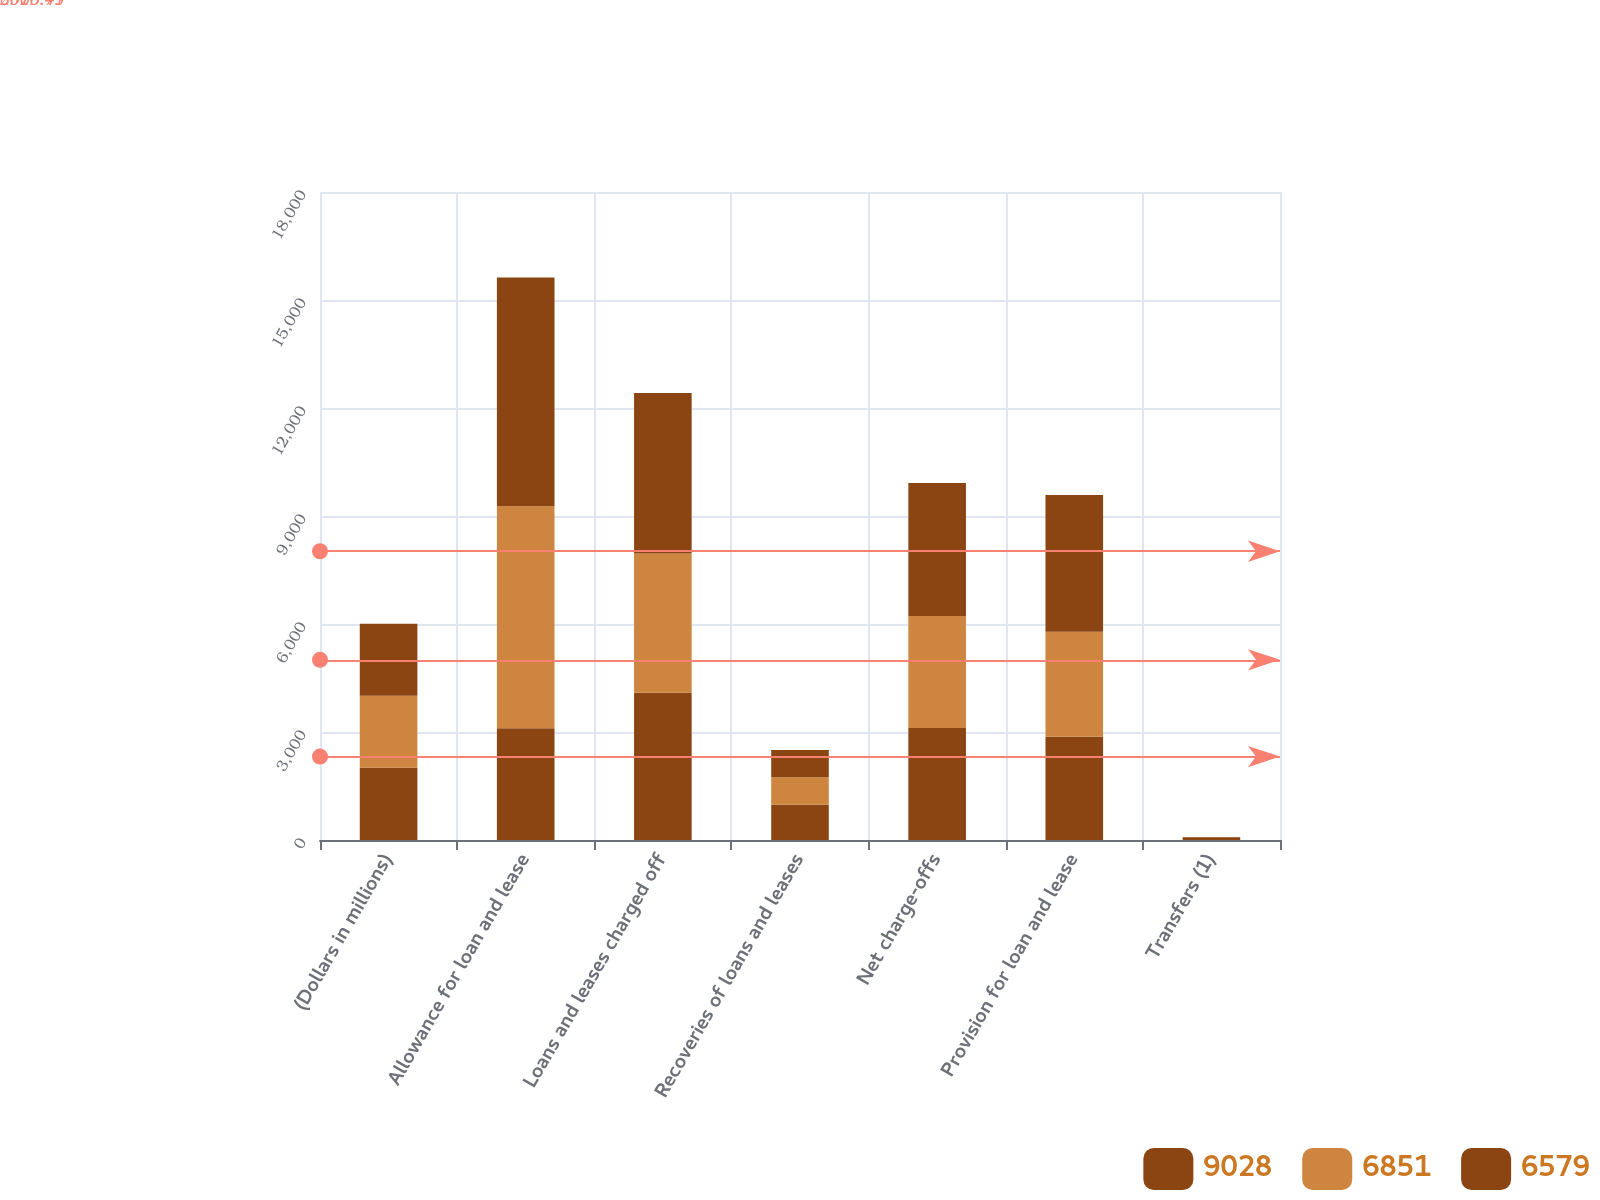Convert chart to OTSL. <chart><loc_0><loc_0><loc_500><loc_500><stacked_bar_chart><ecel><fcel>(Dollars in millions)<fcel>Allowance for loan and lease<fcel>Loans and leases charged off<fcel>Recoveries of loans and leases<fcel>Net charge-offs<fcel>Provision for loan and lease<fcel>Transfers (1)<nl><fcel>9028<fcel>2004<fcel>3106<fcel>4092<fcel>979<fcel>3113<fcel>2868<fcel>55<nl><fcel>6851<fcel>2003<fcel>6163<fcel>3867<fcel>761<fcel>3106<fcel>2916<fcel>5<nl><fcel>6579<fcel>2002<fcel>6358<fcel>4460<fcel>763<fcel>3697<fcel>3801<fcel>24<nl></chart> 